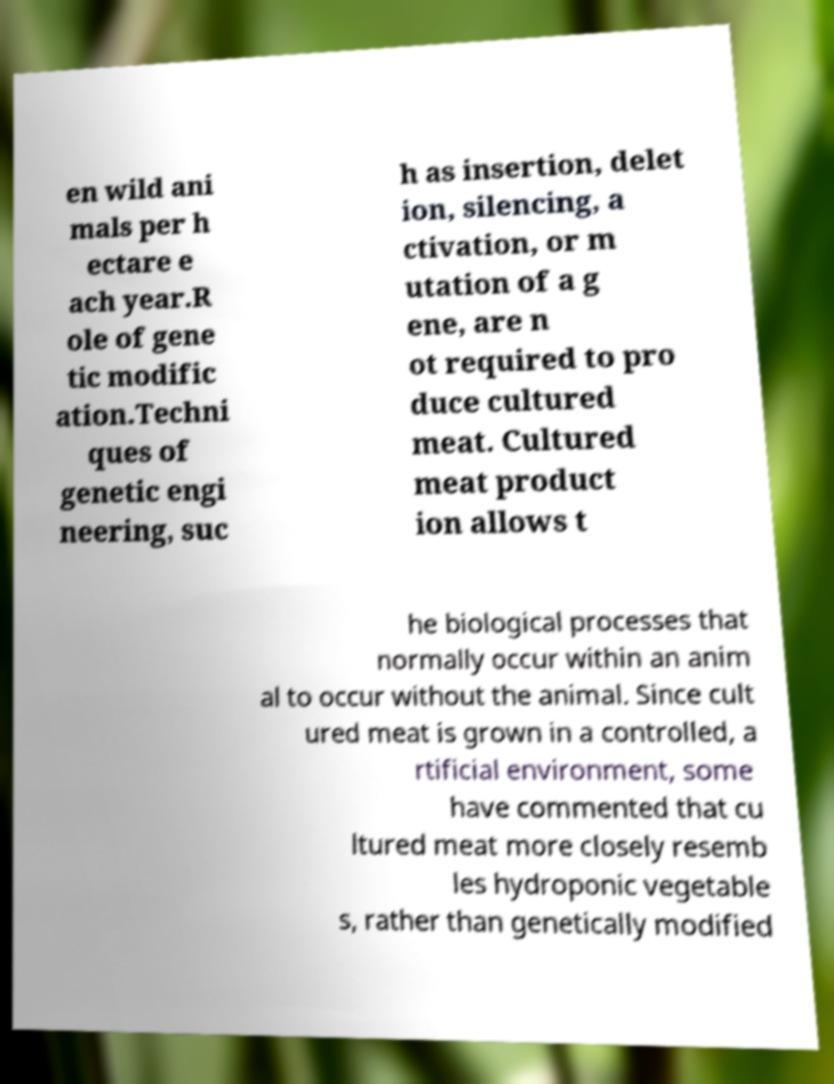Can you read and provide the text displayed in the image?This photo seems to have some interesting text. Can you extract and type it out for me? en wild ani mals per h ectare e ach year.R ole of gene tic modific ation.Techni ques of genetic engi neering, suc h as insertion, delet ion, silencing, a ctivation, or m utation of a g ene, are n ot required to pro duce cultured meat. Cultured meat product ion allows t he biological processes that normally occur within an anim al to occur without the animal. Since cult ured meat is grown in a controlled, a rtificial environment, some have commented that cu ltured meat more closely resemb les hydroponic vegetable s, rather than genetically modified 